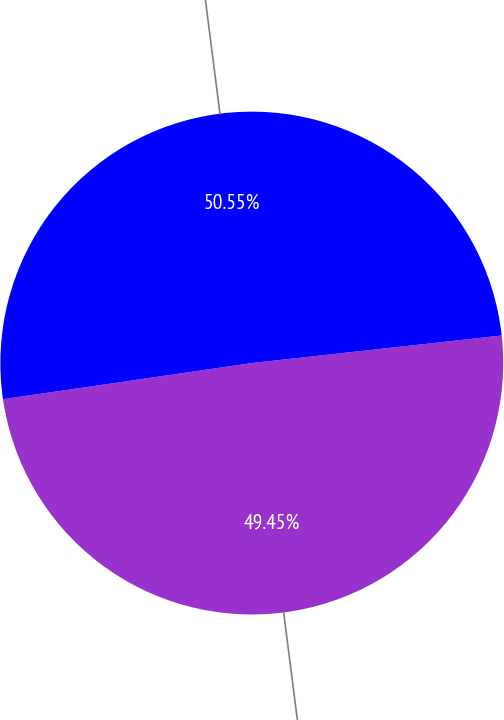Convert chart. <chart><loc_0><loc_0><loc_500><loc_500><pie_chart><fcel>2013<fcel>2012<nl><fcel>49.45%<fcel>50.55%<nl></chart> 